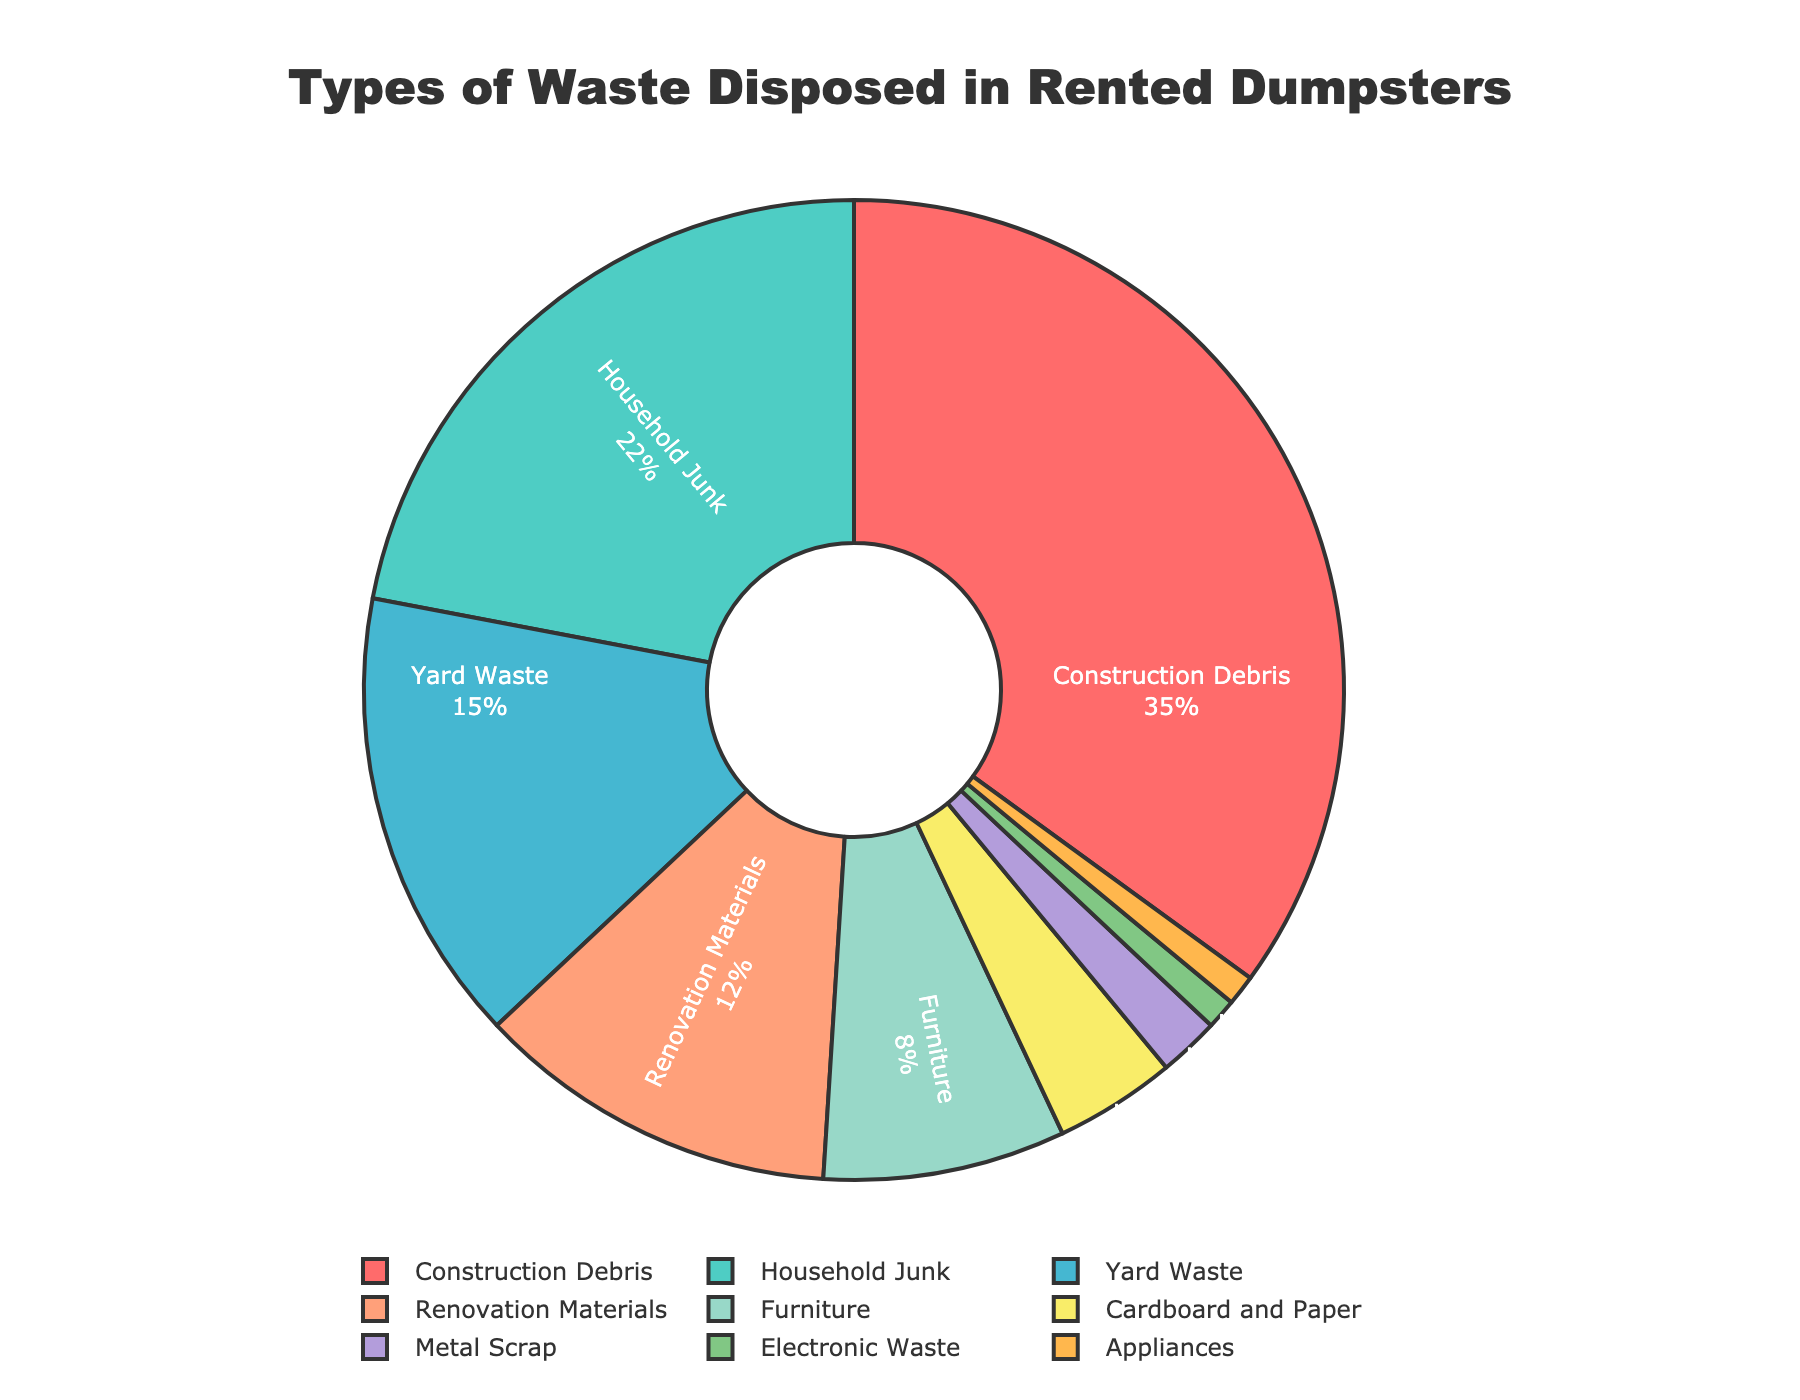What percentage of waste is due to household junk? According to the pie chart, household junk accounts for 22% of the waste disposed in rented dumpsters.
Answer: 22% Which type of waste has the smallest percentage in the pie chart? The pie chart shows that both electronic waste and appliances each account for the smallest percentage of waste, with 1% each.
Answer: Electronic waste and appliances (1% each) What is the total percentage of construction debris and renovation materials combined? To find the total percentage of construction debris and renovation materials, add their individual percentages: 35% (construction debris) + 12% (renovation materials) = 47%.
Answer: 47% Is the percentage of yard waste higher or lower than the percentage of furniture? The pie chart shows yard waste at 15% and furniture at 8%. Therefore, yard waste is higher than furniture.
Answer: Higher How much more significant is the percentage of household junk compared to metal scrap? Household junk is 22%, while metal scrap is 2%. The difference is calculated as 22% - 2% = 20%.
Answer: 20% more What is the combined total percentage of cardboard and paper, metal scrap, electronic waste, and appliances? Add the percentages of these waste types: 4% (cardboard and paper) + 2% (metal scrap) + 1% (electronic waste) + 1% (appliances) = 8%.
Answer: 8% What color represents furniture in the pie chart? According to the pie chart, the section representing furniture is colored green.
Answer: Green Among construction debris, household junk, and yard waste, which has the smallest percentage, and what is it? The pie chart shows construction debris at 35%, household junk at 22%, and yard waste at 15%. Therefore, yard waste has the smallest percentage of these three.
Answer: Yard waste (15%) If you were to combine the total percentage of construction debris, household junk, and yard waste, what would it be? Add the percentages of construction debris (35%), household junk (22%), and yard waste (15%): 35% + 22% + 15% = 72%.
Answer: 72% Is the contribution of electronic waste equal to the contribution of appliances? The pie chart indicates that both electronic waste and appliances each account for 1% of the total waste, so their contributions are equal.
Answer: Equal (1% each) 